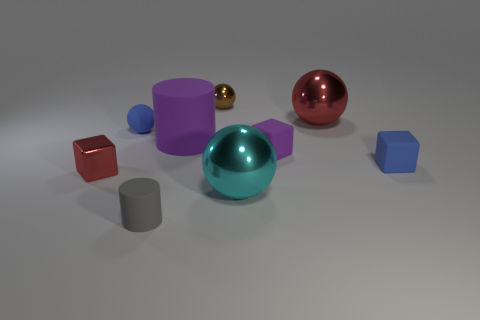Add 1 matte blocks. How many objects exist? 10 Subtract all cylinders. How many objects are left? 7 Add 9 small matte balls. How many small matte balls exist? 10 Subtract 0 purple spheres. How many objects are left? 9 Subtract all purple shiny cylinders. Subtract all large cyan balls. How many objects are left? 8 Add 4 large cyan shiny balls. How many large cyan shiny balls are left? 5 